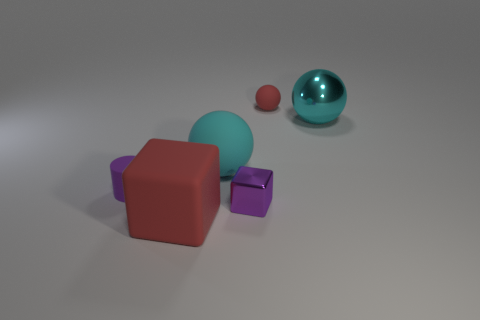What is the texture of the objects like? The objects seem to have a smooth texture, particularly noticeable on the reflective surface of the cyan sphere which mirrors the environment. 